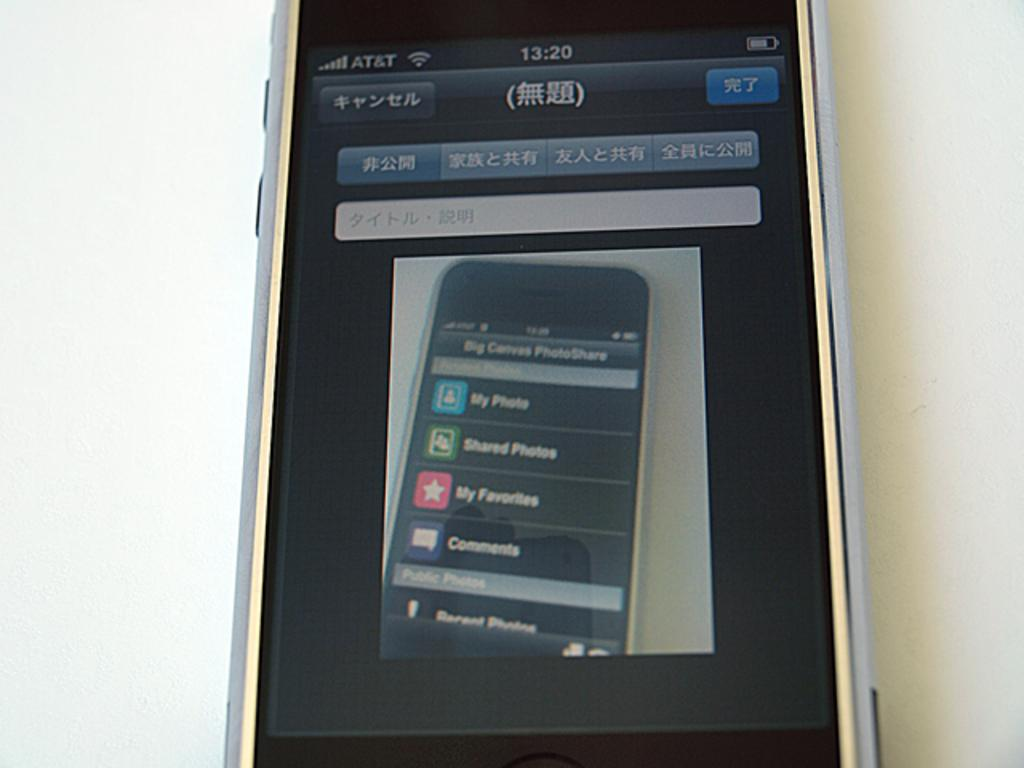<image>
Provide a brief description of the given image. An AT&T cell phone has a display of another phone. 